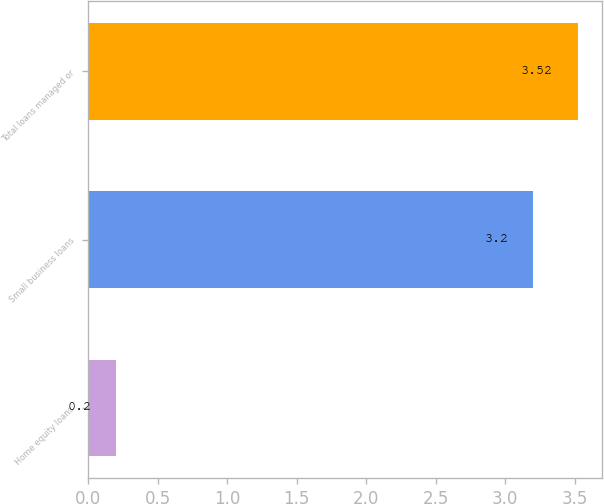<chart> <loc_0><loc_0><loc_500><loc_500><bar_chart><fcel>Home equity loans<fcel>Small business loans<fcel>Total loans managed or<nl><fcel>0.2<fcel>3.2<fcel>3.52<nl></chart> 